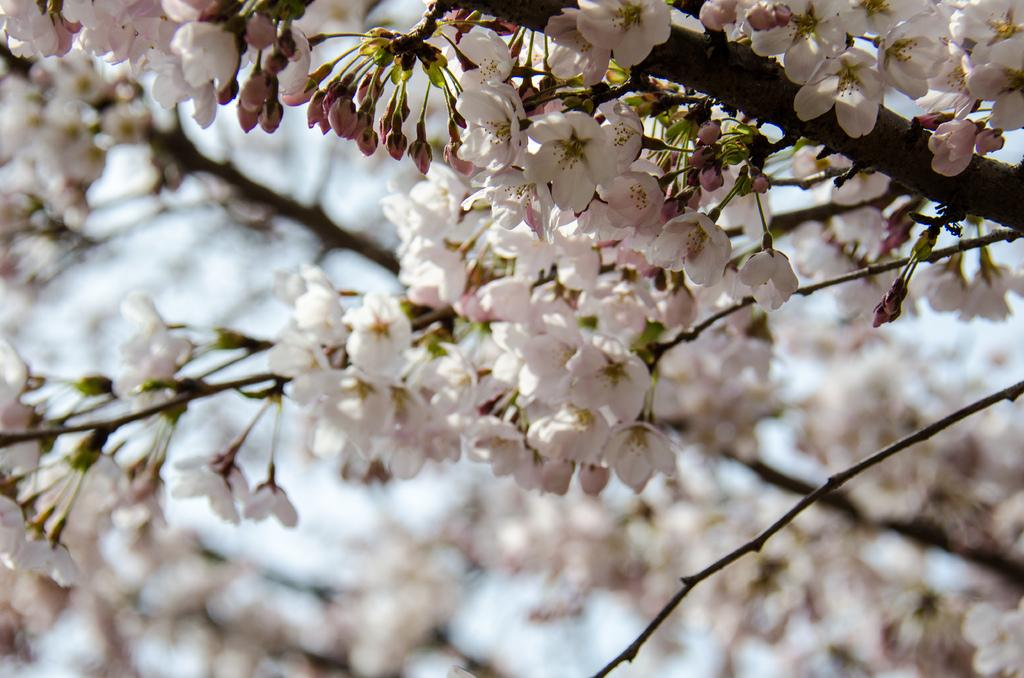What type of flowers can be seen in the image? There are many white color flowers in the image. Can you describe the growth stage of the flowers? There are buds on the stems of the flowers. What can be seen in the background of the image? The sky is visible in the background of the image. Where is the tiger hiding in the image? There is no tiger present in the image. What type of calculator is being used to measure the flowers in the image? There is no calculator present in the image, and the flowers are not being measured. 